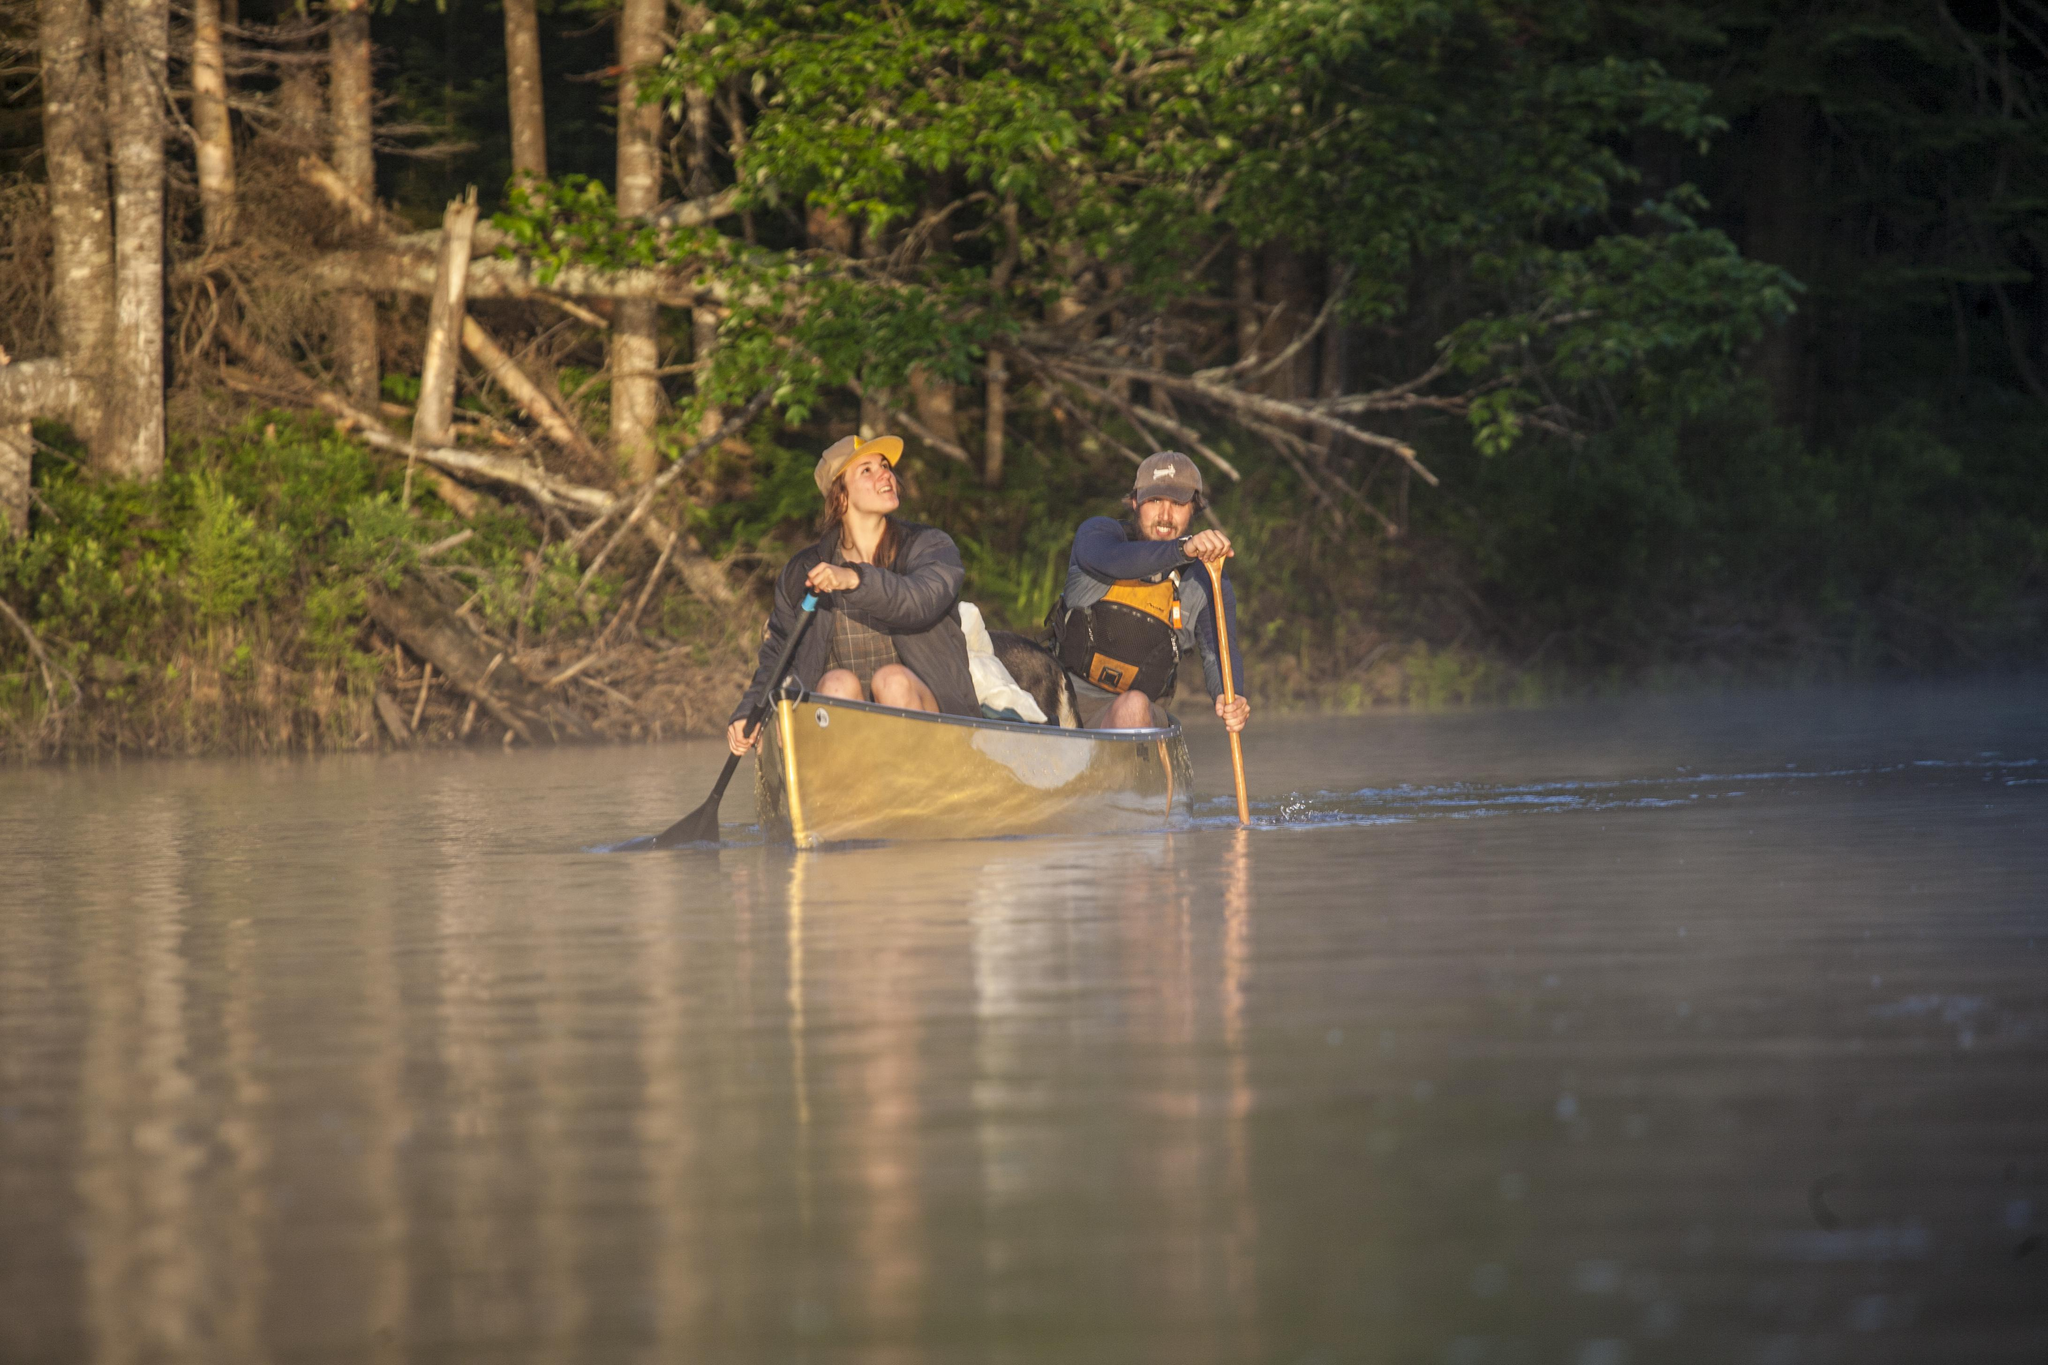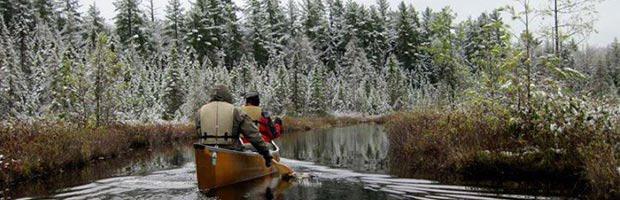The first image is the image on the left, the second image is the image on the right. Given the left and right images, does the statement "One image contains at least one red canoe on water, and the other contains at least one beige canoe." hold true? Answer yes or no. No. The first image is the image on the left, the second image is the image on the right. Assess this claim about the two images: "There are no more than 4 canoeists.". Correct or not? Answer yes or no. Yes. 